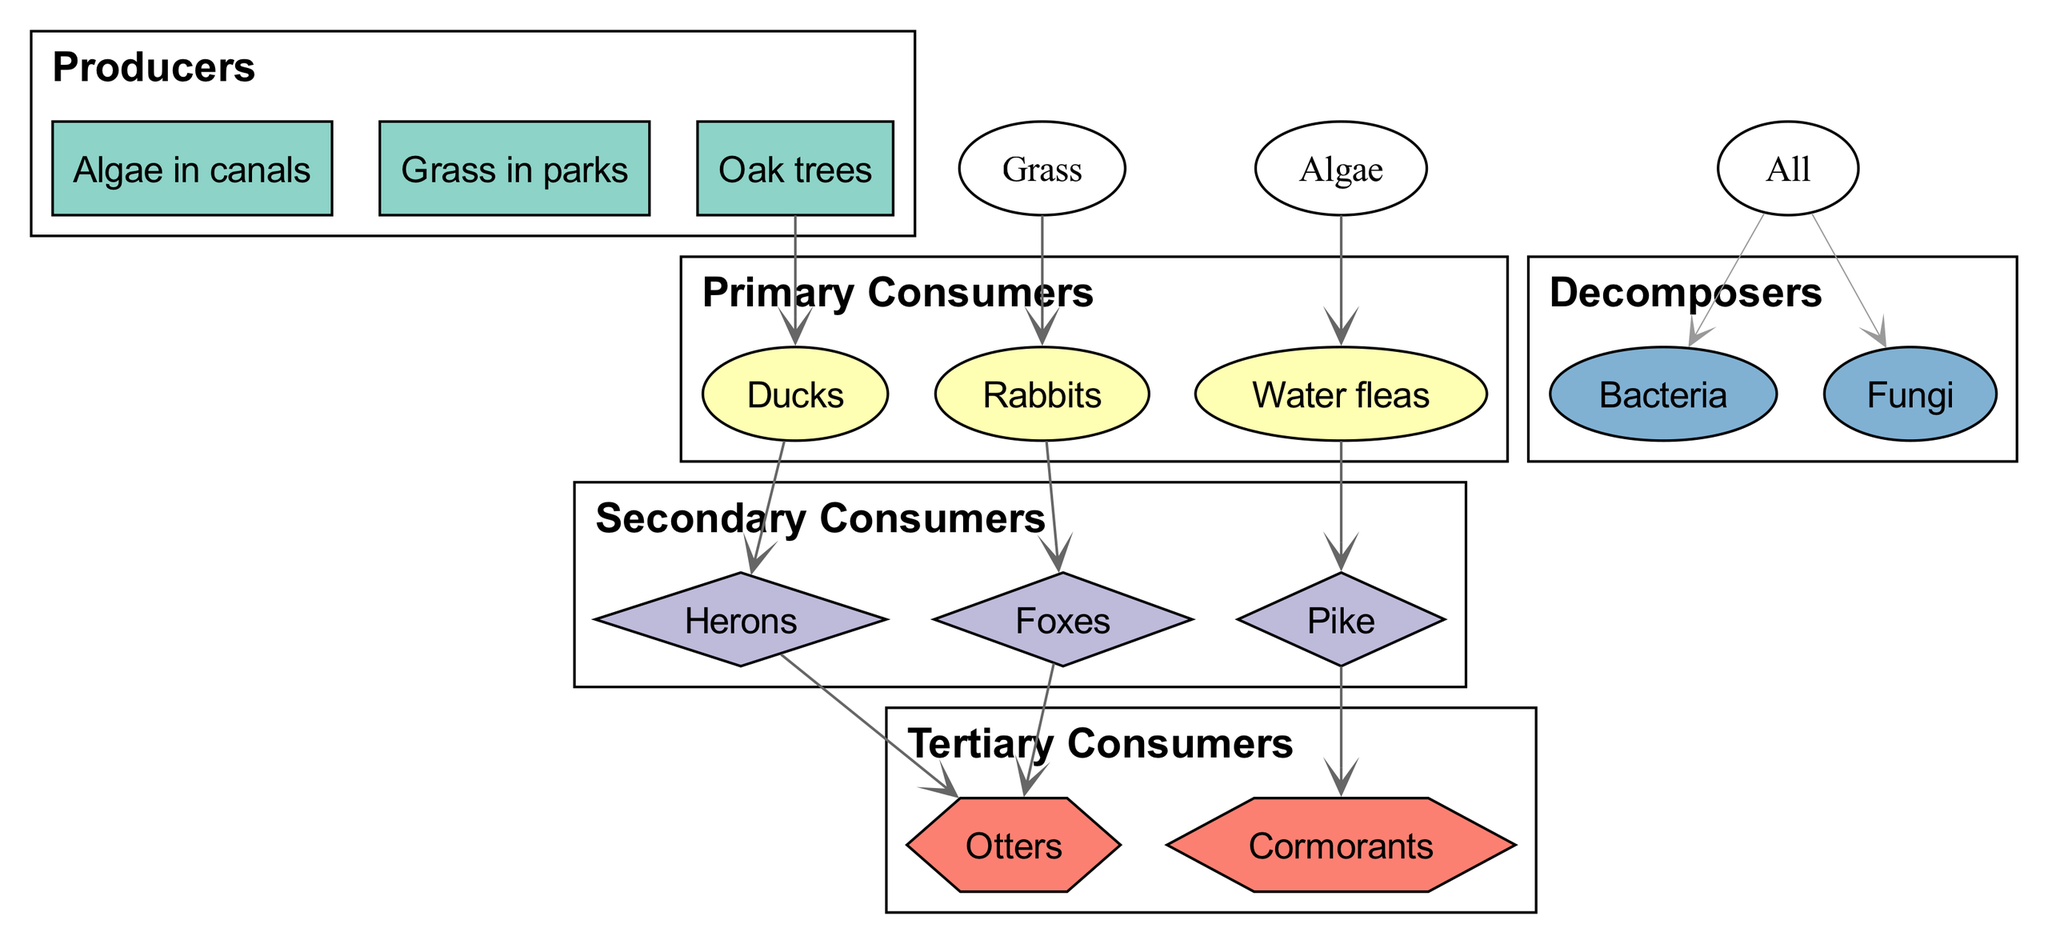What are the primary consumers in this food chain? The diagram categorizes the organisms into different trophic levels. Looking at the "Primary Consumers" section, the listed organisms are Ducks, Water fleas, and Rabbits.
Answer: Ducks, Water fleas, Rabbits How many producers are there in the diagram? By examining the "Producers" section of the diagram, we can see three organisms: Algae in canals, Grass in parks, and Oak trees. Therefore, the total number of producers is three.
Answer: 3 Which secondary consumer is connected to the Ducks? In the "Secondary Consumers" section, we find that Ducks are linked to Herons as per the relationship "Ducks → Herons." This indicates that the Herons prey on the Ducks.
Answer: Herons What is the role of Bacteria and Fungi in the food chain? The "Decomposers" category shows that Bacteria and Fungi break down organic matter from all organisms in the food chain. The relationship "All → Bacteria and Fungi" indicates their role as decomposers.
Answer: Decomposers Who are the tertiary consumers in this chain? In the diagram, the "Tertiary Consumers" section lists Cormorants and Otters as the top predators that consume secondary consumers. Hence, they are recognized as tertiary consumers of this food chain.
Answer: Cormorants, Otters How many edges are there connecting primary consumers to secondary consumers? By counting the relationships involving primary consumers (Ducks and Rabbits) leading to secondary consumers (Herons and Foxes), we observe that there are two connections in total (Ducks to Herons and Rabbits to Foxes).
Answer: 2 Which organism is at the top of the food chain? The "Tertiary Consumers" section contains Cormorants and Otters, and since tertiary consumers represent the highest trophic level in this diagram, they are at the top of the food chain.
Answer: Cormorants, Otters How many relationships involve decomposers? There is only one relationship involving decomposers in the diagram, which is shown as "All → Bacteria and Fungi," indicating that all other organisms contribute to the role of decomposers.
Answer: 1 